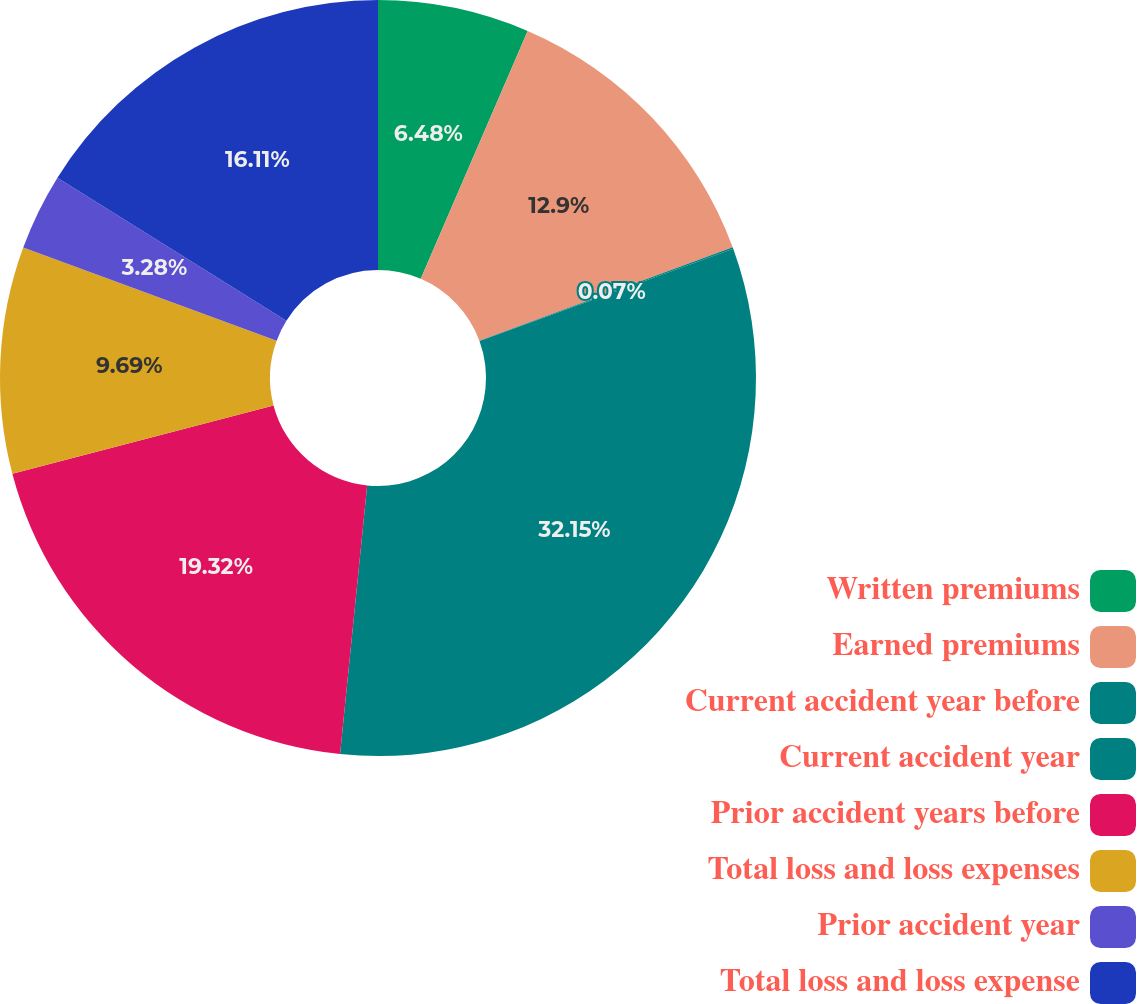<chart> <loc_0><loc_0><loc_500><loc_500><pie_chart><fcel>Written premiums<fcel>Earned premiums<fcel>Current accident year before<fcel>Current accident year<fcel>Prior accident years before<fcel>Total loss and loss expenses<fcel>Prior accident year<fcel>Total loss and loss expense<nl><fcel>6.48%<fcel>12.9%<fcel>0.07%<fcel>32.15%<fcel>19.32%<fcel>9.69%<fcel>3.28%<fcel>16.11%<nl></chart> 